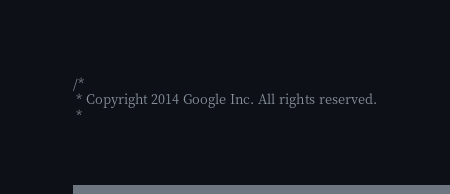<code> <loc_0><loc_0><loc_500><loc_500><_C_>/*
 * Copyright 2014 Google Inc. All rights reserved.
 *</code> 